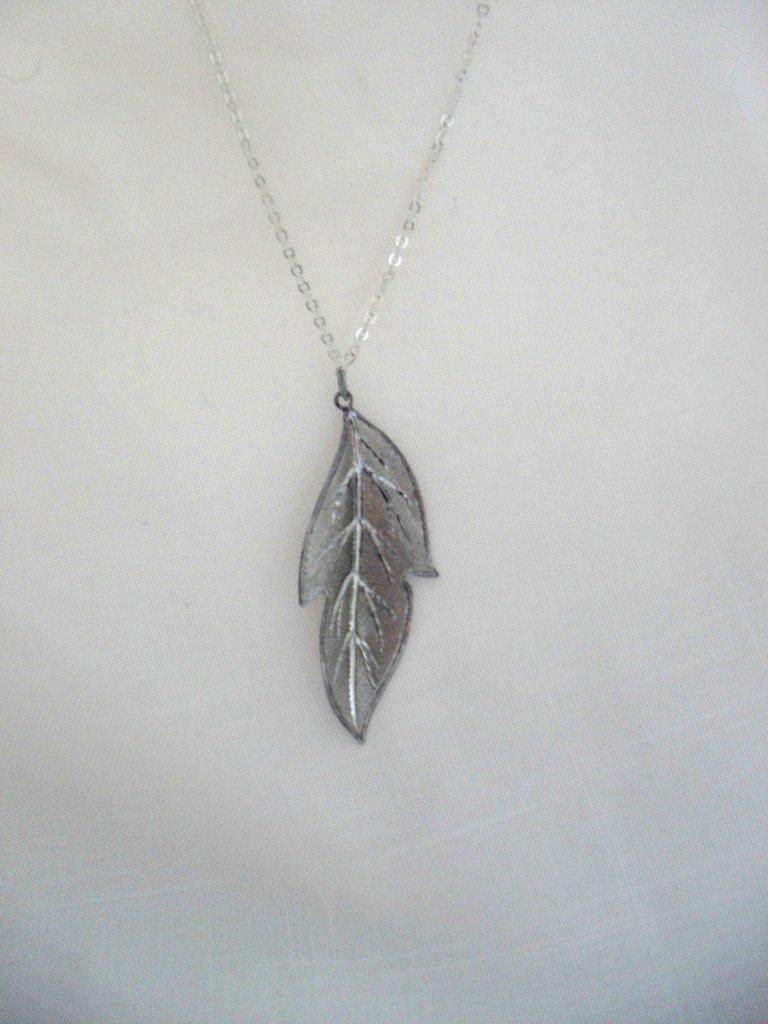What is the main object in the image? There is a pendant in the image. What is connected to the pendant? There is a chain connected to the pendant. What is the pendant and chain placed on? The pendant and chain are on a white platform. How many cars are parked on the street in the image? There are no cars or streets present in the image; it features a pendant and chain on a white platform. 